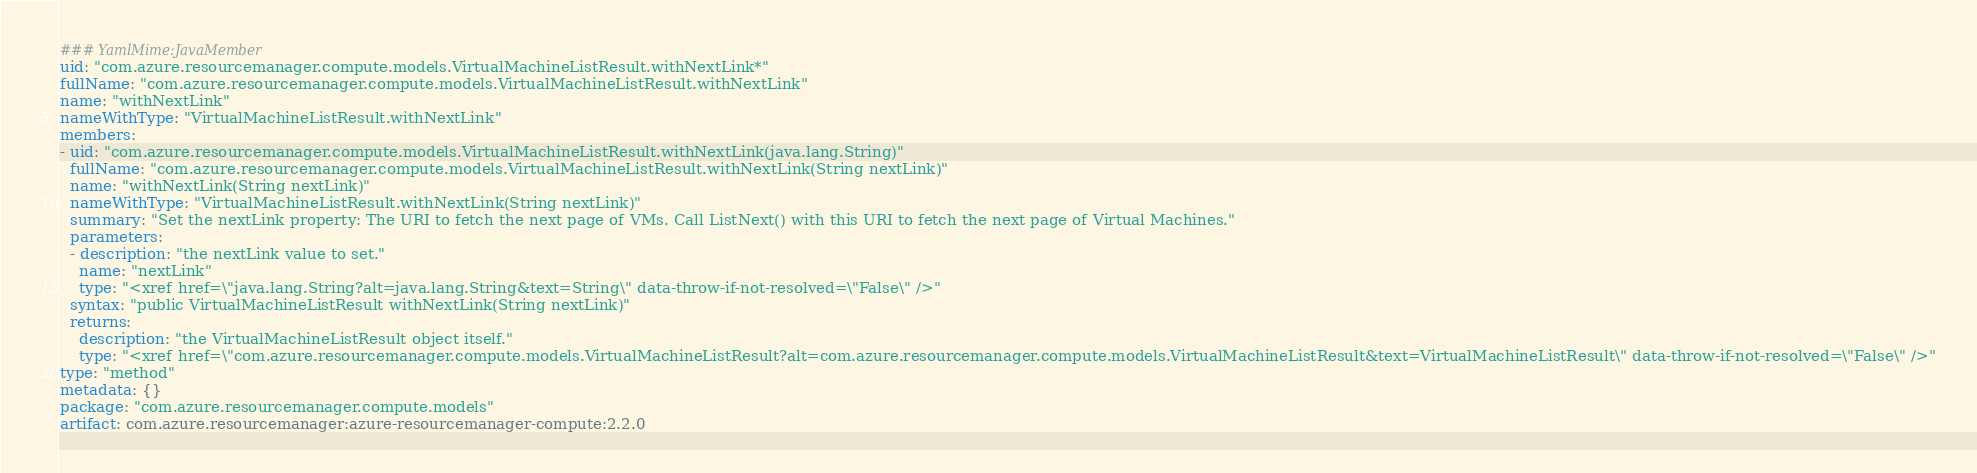Convert code to text. <code><loc_0><loc_0><loc_500><loc_500><_YAML_>### YamlMime:JavaMember
uid: "com.azure.resourcemanager.compute.models.VirtualMachineListResult.withNextLink*"
fullName: "com.azure.resourcemanager.compute.models.VirtualMachineListResult.withNextLink"
name: "withNextLink"
nameWithType: "VirtualMachineListResult.withNextLink"
members:
- uid: "com.azure.resourcemanager.compute.models.VirtualMachineListResult.withNextLink(java.lang.String)"
  fullName: "com.azure.resourcemanager.compute.models.VirtualMachineListResult.withNextLink(String nextLink)"
  name: "withNextLink(String nextLink)"
  nameWithType: "VirtualMachineListResult.withNextLink(String nextLink)"
  summary: "Set the nextLink property: The URI to fetch the next page of VMs. Call ListNext() with this URI to fetch the next page of Virtual Machines."
  parameters:
  - description: "the nextLink value to set."
    name: "nextLink"
    type: "<xref href=\"java.lang.String?alt=java.lang.String&text=String\" data-throw-if-not-resolved=\"False\" />"
  syntax: "public VirtualMachineListResult withNextLink(String nextLink)"
  returns:
    description: "the VirtualMachineListResult object itself."
    type: "<xref href=\"com.azure.resourcemanager.compute.models.VirtualMachineListResult?alt=com.azure.resourcemanager.compute.models.VirtualMachineListResult&text=VirtualMachineListResult\" data-throw-if-not-resolved=\"False\" />"
type: "method"
metadata: {}
package: "com.azure.resourcemanager.compute.models"
artifact: com.azure.resourcemanager:azure-resourcemanager-compute:2.2.0
</code> 